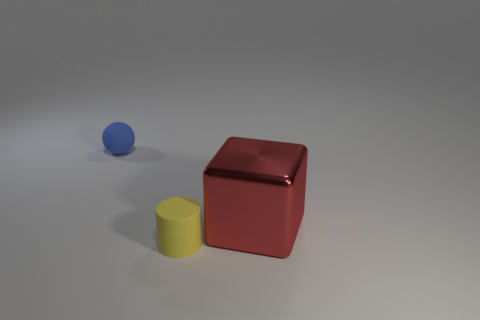Are there any other things that are the same material as the large red object?
Keep it short and to the point. No. What number of big objects are either blue balls or yellow rubber cylinders?
Offer a terse response. 0. What is the block made of?
Your answer should be compact. Metal. What number of other objects are the same shape as the tiny blue object?
Provide a succinct answer. 0. The yellow rubber object has what size?
Ensure brevity in your answer.  Small. There is a object that is behind the cylinder and left of the red object; what size is it?
Ensure brevity in your answer.  Small. What shape is the rubber object that is in front of the large object?
Your response must be concise. Cylinder. Are the blue ball and the thing that is to the right of the yellow cylinder made of the same material?
Your answer should be very brief. No. Is the shape of the red metal thing the same as the blue matte thing?
Keep it short and to the point. No. There is a object that is both behind the yellow matte object and in front of the blue matte sphere; what is its color?
Your response must be concise. Red. 